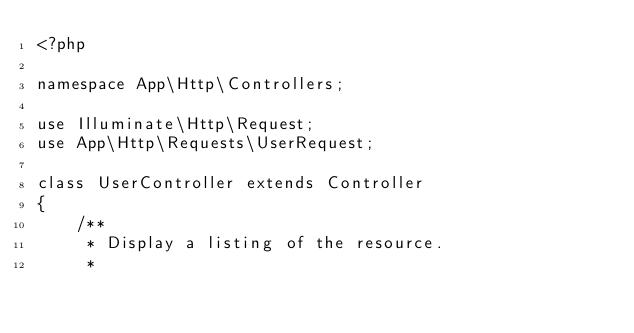<code> <loc_0><loc_0><loc_500><loc_500><_PHP_><?php

namespace App\Http\Controllers;

use Illuminate\Http\Request;
use App\Http\Requests\UserRequest;

class UserController extends Controller
{
    /**
     * Display a listing of the resource.
     *</code> 